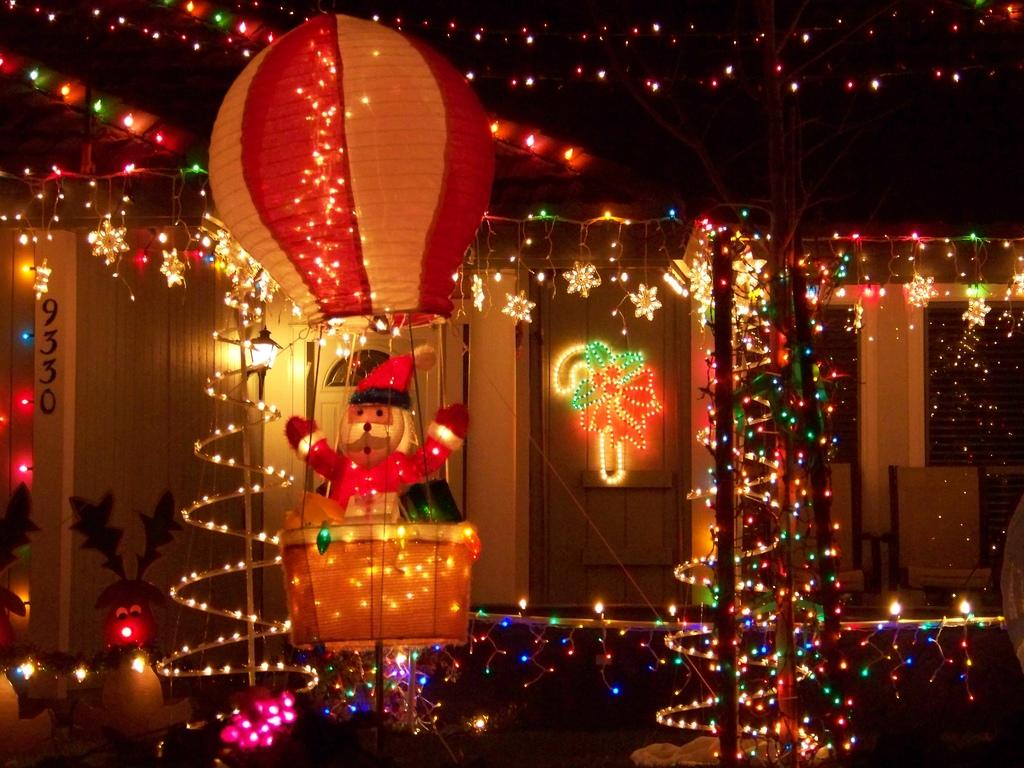What types of items can be seen in the image? There are decorative items in the image. Are there any sources of light visible? Yes, there are lights in the image. What architectural features can be observed? There are windows, a door, and a wall in the image. What type of furniture is present? There are chairs in the image. What is the overall appearance of the background? The background of the image is dark. What type of toothpaste is being used in the image? There is no toothpaste present in the image. What action is taking place in the image? The image does not depict any specific action; it shows various items and features in a room. 